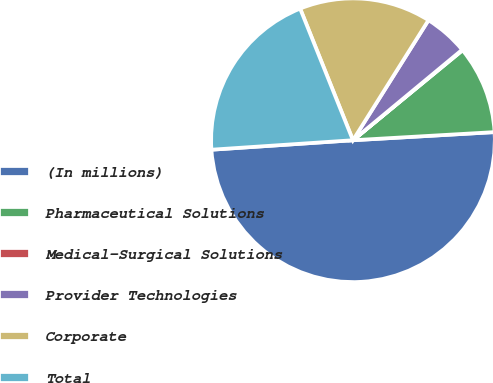Convert chart to OTSL. <chart><loc_0><loc_0><loc_500><loc_500><pie_chart><fcel>(In millions)<fcel>Pharmaceutical Solutions<fcel>Medical-Surgical Solutions<fcel>Provider Technologies<fcel>Corporate<fcel>Total<nl><fcel>49.85%<fcel>10.03%<fcel>0.07%<fcel>5.05%<fcel>15.01%<fcel>19.99%<nl></chart> 